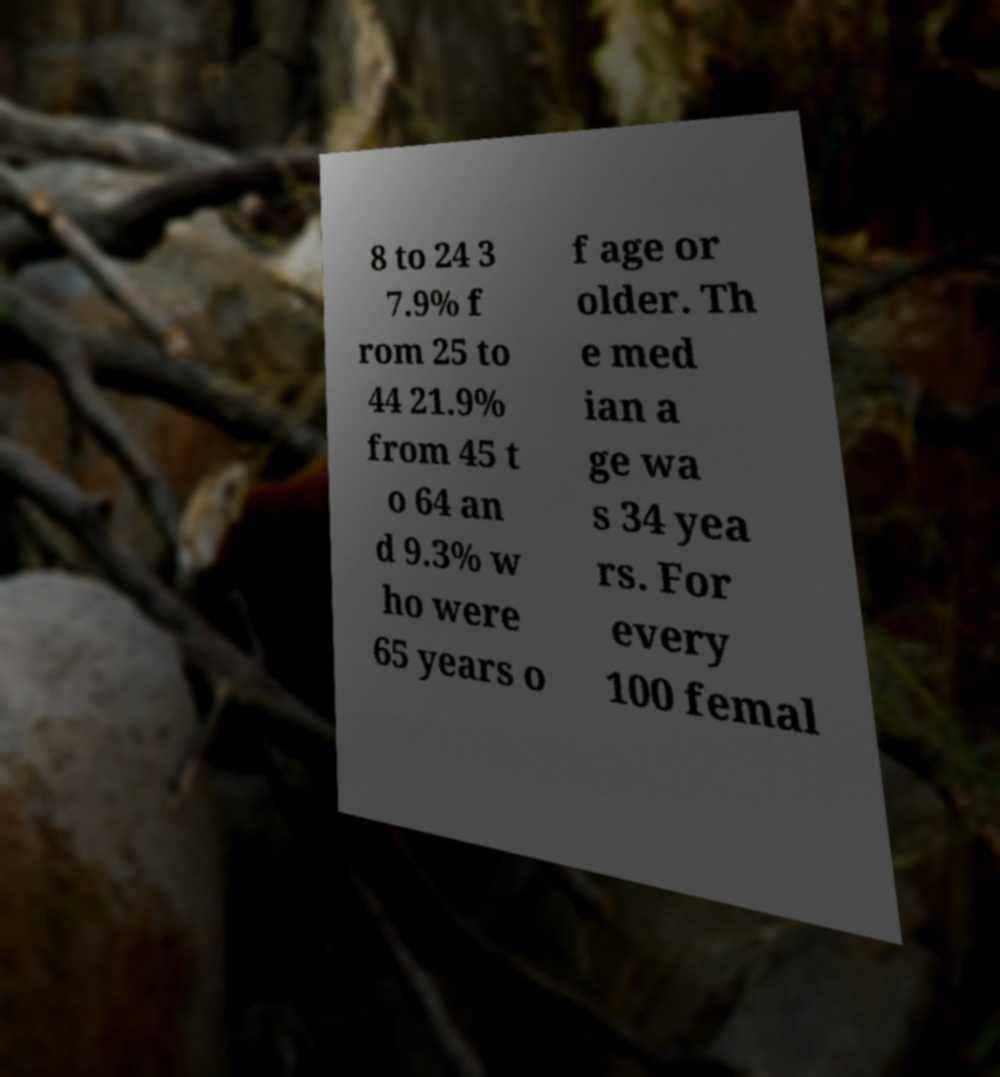Could you assist in decoding the text presented in this image and type it out clearly? 8 to 24 3 7.9% f rom 25 to 44 21.9% from 45 t o 64 an d 9.3% w ho were 65 years o f age or older. Th e med ian a ge wa s 34 yea rs. For every 100 femal 